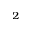Convert formula to latex. <formula><loc_0><loc_0><loc_500><loc_500>^ { 2 }</formula> 